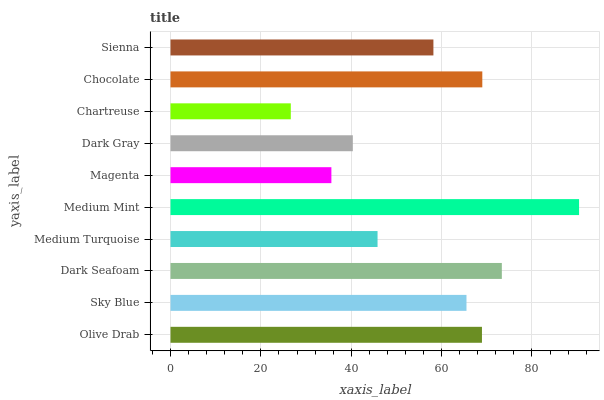Is Chartreuse the minimum?
Answer yes or no. Yes. Is Medium Mint the maximum?
Answer yes or no. Yes. Is Sky Blue the minimum?
Answer yes or no. No. Is Sky Blue the maximum?
Answer yes or no. No. Is Olive Drab greater than Sky Blue?
Answer yes or no. Yes. Is Sky Blue less than Olive Drab?
Answer yes or no. Yes. Is Sky Blue greater than Olive Drab?
Answer yes or no. No. Is Olive Drab less than Sky Blue?
Answer yes or no. No. Is Sky Blue the high median?
Answer yes or no. Yes. Is Sienna the low median?
Answer yes or no. Yes. Is Medium Turquoise the high median?
Answer yes or no. No. Is Olive Drab the low median?
Answer yes or no. No. 